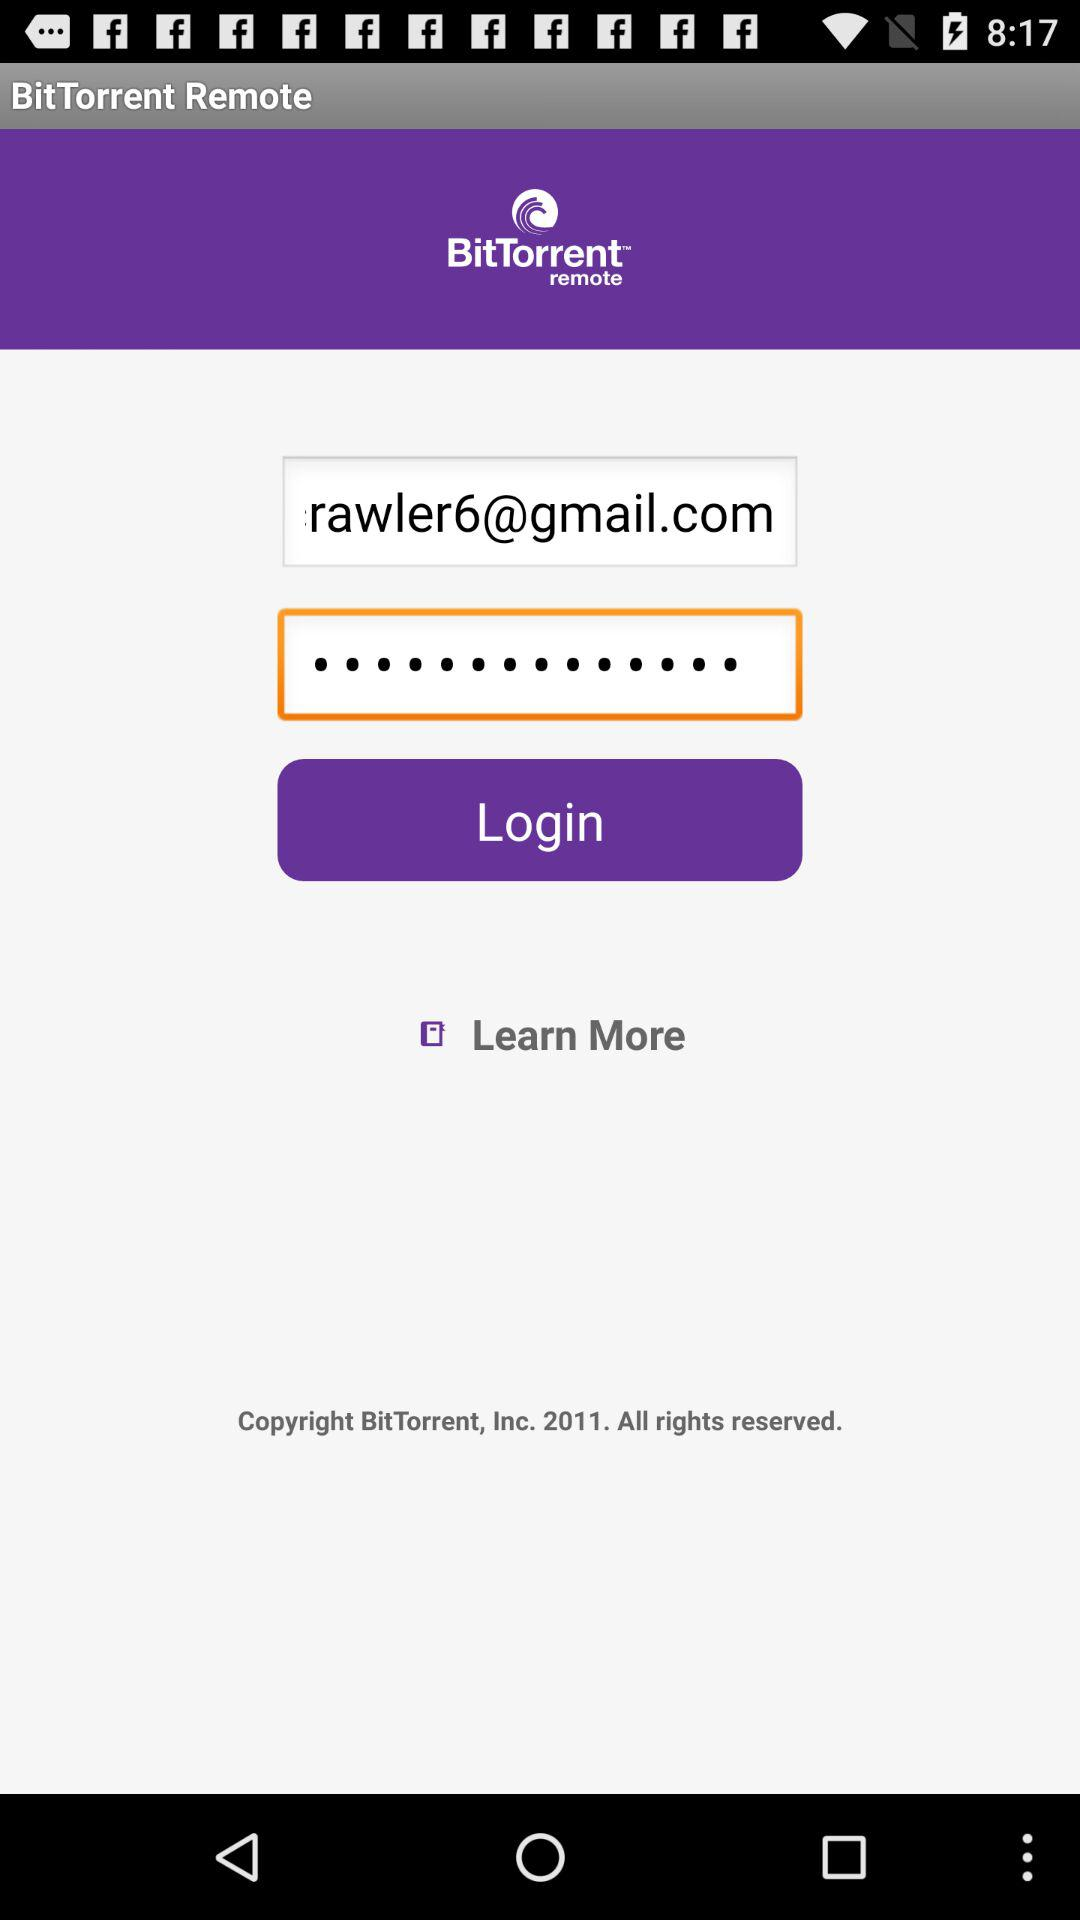What is the email address?
When the provided information is insufficient, respond with <no answer>. <no answer> 